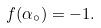Convert formula to latex. <formula><loc_0><loc_0><loc_500><loc_500>f ( \alpha _ { \circ } ) = - 1 .</formula> 